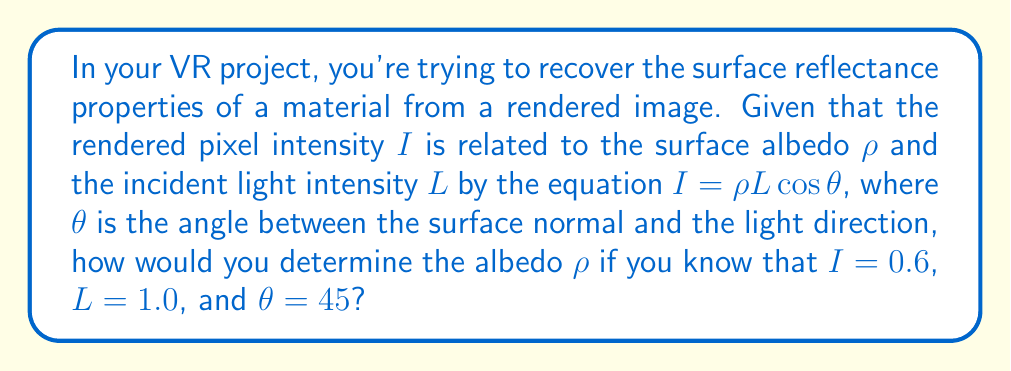Give your solution to this math problem. To solve this problem, we'll follow these steps:

1. Recall the given equation:
   $I = \rho L \cos\theta$

2. Substitute the known values:
   $0.6 = \rho \cdot 1.0 \cdot \cos(45°)$

3. Simplify the right side of the equation:
   $\cos(45°) = \frac{1}{\sqrt{2}} \approx 0.7071$
   
   So, our equation becomes:
   $0.6 = \rho \cdot 0.7071$

4. Solve for $\rho$:
   $\rho = \frac{0.6}{0.7071}$

5. Calculate the final value:
   $\rho \approx 0.8485$

This value represents the albedo of the surface, which is a measure of its reflectivity. In the context of VR content creation, accurately recovering this value is crucial for realistic rendering of materials in virtual environments.
Answer: $\rho \approx 0.8485$ 